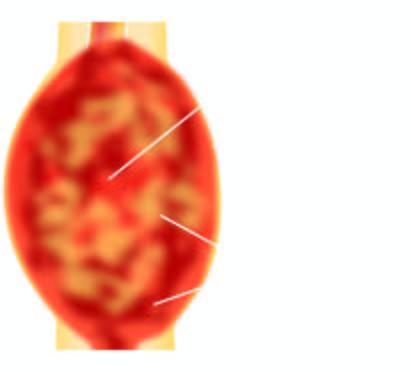s the epidermis grey-white, cystic, soft and friable?
Answer the question using a single word or phrase. No 